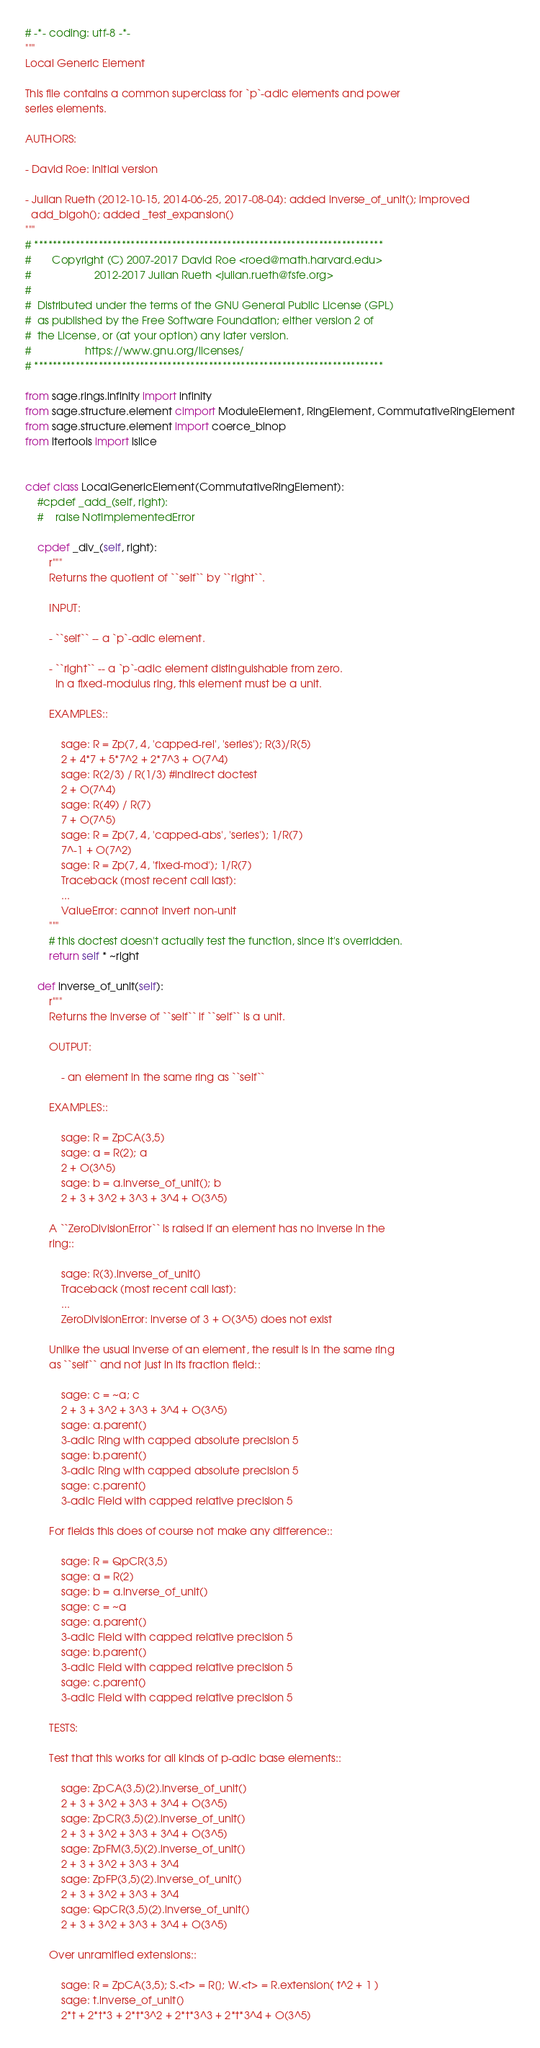Convert code to text. <code><loc_0><loc_0><loc_500><loc_500><_Cython_># -*- coding: utf-8 -*-
"""
Local Generic Element

This file contains a common superclass for `p`-adic elements and power
series elements.

AUTHORS:

- David Roe: initial version

- Julian Rueth (2012-10-15, 2014-06-25, 2017-08-04): added inverse_of_unit(); improved
  add_bigoh(); added _test_expansion()
"""
# ****************************************************************************
#       Copyright (C) 2007-2017 David Roe <roed@math.harvard.edu>
#                     2012-2017 Julian Rueth <julian.rueth@fsfe.org>
#
#  Distributed under the terms of the GNU General Public License (GPL)
#  as published by the Free Software Foundation; either version 2 of
#  the License, or (at your option) any later version.
#                  https://www.gnu.org/licenses/
# ****************************************************************************

from sage.rings.infinity import infinity
from sage.structure.element cimport ModuleElement, RingElement, CommutativeRingElement
from sage.structure.element import coerce_binop
from itertools import islice


cdef class LocalGenericElement(CommutativeRingElement):
    #cpdef _add_(self, right):
    #    raise NotImplementedError

    cpdef _div_(self, right):
        r"""
        Returns the quotient of ``self`` by ``right``.

        INPUT:

        - ``self`` -- a `p`-adic element.

        - ``right`` -- a `p`-adic element distinguishable from zero.
          In a fixed-modulus ring, this element must be a unit.

        EXAMPLES::

            sage: R = Zp(7, 4, 'capped-rel', 'series'); R(3)/R(5)
            2 + 4*7 + 5*7^2 + 2*7^3 + O(7^4)
            sage: R(2/3) / R(1/3) #indirect doctest
            2 + O(7^4)
            sage: R(49) / R(7)
            7 + O(7^5)
            sage: R = Zp(7, 4, 'capped-abs', 'series'); 1/R(7)
            7^-1 + O(7^2)
            sage: R = Zp(7, 4, 'fixed-mod'); 1/R(7)
            Traceback (most recent call last):
            ...
            ValueError: cannot invert non-unit
        """
        # this doctest doesn't actually test the function, since it's overridden.
        return self * ~right

    def inverse_of_unit(self):
        r"""
        Returns the inverse of ``self`` if ``self`` is a unit.

        OUTPUT:

            - an element in the same ring as ``self``

        EXAMPLES::

            sage: R = ZpCA(3,5)
            sage: a = R(2); a
            2 + O(3^5)
            sage: b = a.inverse_of_unit(); b
            2 + 3 + 3^2 + 3^3 + 3^4 + O(3^5)

        A ``ZeroDivisionError`` is raised if an element has no inverse in the
        ring::

            sage: R(3).inverse_of_unit()
            Traceback (most recent call last):
            ...
            ZeroDivisionError: inverse of 3 + O(3^5) does not exist

        Unlike the usual inverse of an element, the result is in the same ring
        as ``self`` and not just in its fraction field::

            sage: c = ~a; c
            2 + 3 + 3^2 + 3^3 + 3^4 + O(3^5)
            sage: a.parent()
            3-adic Ring with capped absolute precision 5
            sage: b.parent()
            3-adic Ring with capped absolute precision 5
            sage: c.parent()
            3-adic Field with capped relative precision 5

        For fields this does of course not make any difference::

            sage: R = QpCR(3,5)
            sage: a = R(2)
            sage: b = a.inverse_of_unit()
            sage: c = ~a
            sage: a.parent()
            3-adic Field with capped relative precision 5
            sage: b.parent()
            3-adic Field with capped relative precision 5
            sage: c.parent()
            3-adic Field with capped relative precision 5

        TESTS:

        Test that this works for all kinds of p-adic base elements::

            sage: ZpCA(3,5)(2).inverse_of_unit()
            2 + 3 + 3^2 + 3^3 + 3^4 + O(3^5)
            sage: ZpCR(3,5)(2).inverse_of_unit()
            2 + 3 + 3^2 + 3^3 + 3^4 + O(3^5)
            sage: ZpFM(3,5)(2).inverse_of_unit()
            2 + 3 + 3^2 + 3^3 + 3^4
            sage: ZpFP(3,5)(2).inverse_of_unit()
            2 + 3 + 3^2 + 3^3 + 3^4
            sage: QpCR(3,5)(2).inverse_of_unit()
            2 + 3 + 3^2 + 3^3 + 3^4 + O(3^5)

        Over unramified extensions::

            sage: R = ZpCA(3,5); S.<t> = R[]; W.<t> = R.extension( t^2 + 1 )
            sage: t.inverse_of_unit()
            2*t + 2*t*3 + 2*t*3^2 + 2*t*3^3 + 2*t*3^4 + O(3^5)
</code> 